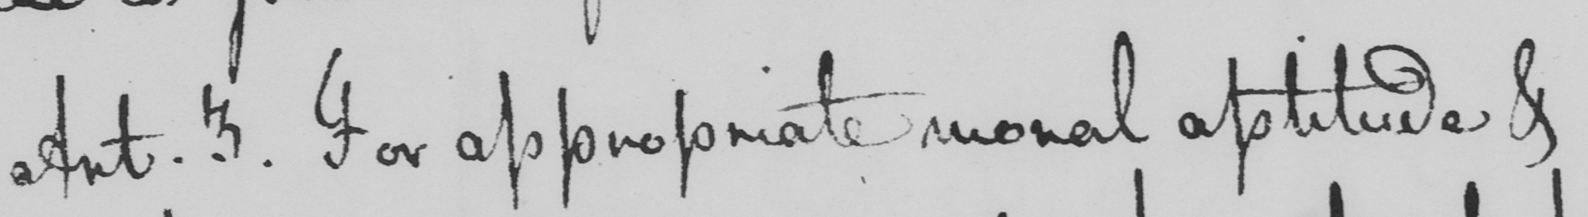Please transcribe the handwritten text in this image. Art . 3 . For appropriate moral aptitude & 